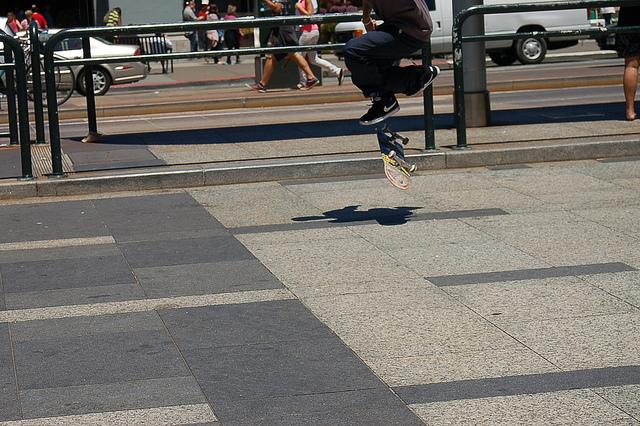Is the skateboarder casting a shadow?
Be succinct. Yes. Is the person moving?
Answer briefly. Yes. What brand of shoe is the guy wearing over the skateboard?
Answer briefly. Nike. Where is the man?
Answer briefly. In air. 